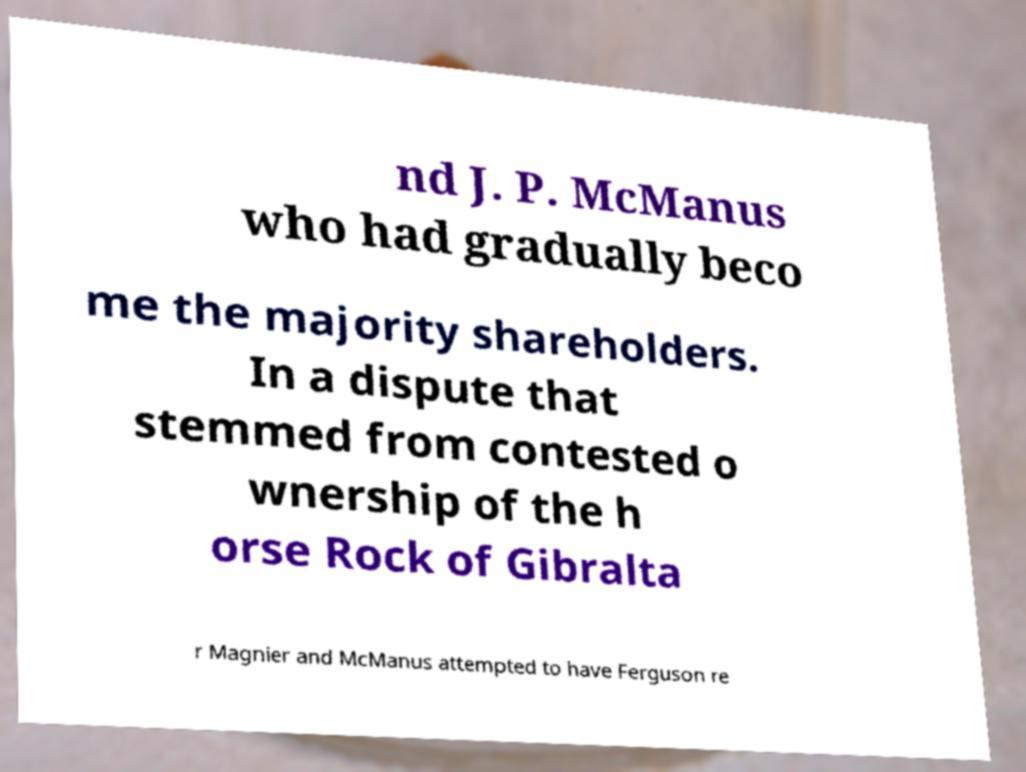Can you read and provide the text displayed in the image?This photo seems to have some interesting text. Can you extract and type it out for me? nd J. P. McManus who had gradually beco me the majority shareholders. In a dispute that stemmed from contested o wnership of the h orse Rock of Gibralta r Magnier and McManus attempted to have Ferguson re 